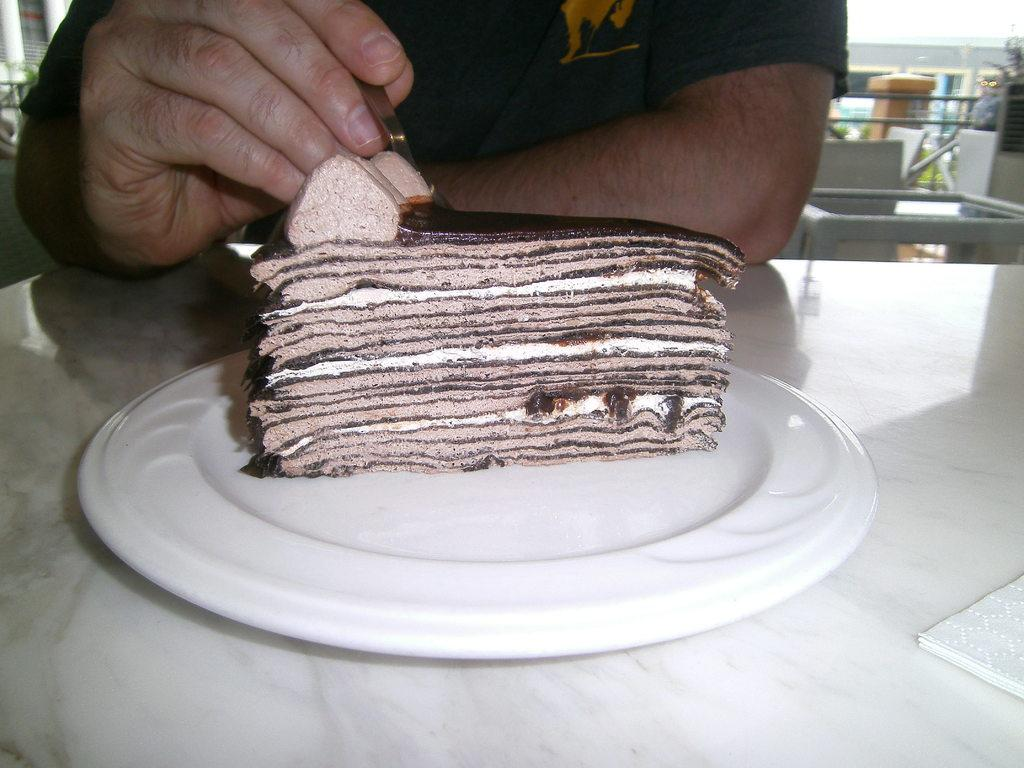What is on the plate in the image? There is a cake piece in a plate in the image. What can be seen on the table in the image? There are tissue papers on a table in the image. What is the person in the background doing? In the background, there is a person holding a spoon in their hand. What type of table is visible in the background? There is a glass table in the background. What architectural features can be seen in the background? There are pillars visible in the background. What other objects are present in the background? There are other objects present in the background. How many books are stacked on the cake in the image? There are no books present in the image, and the cake does not have any books stacked on it. 